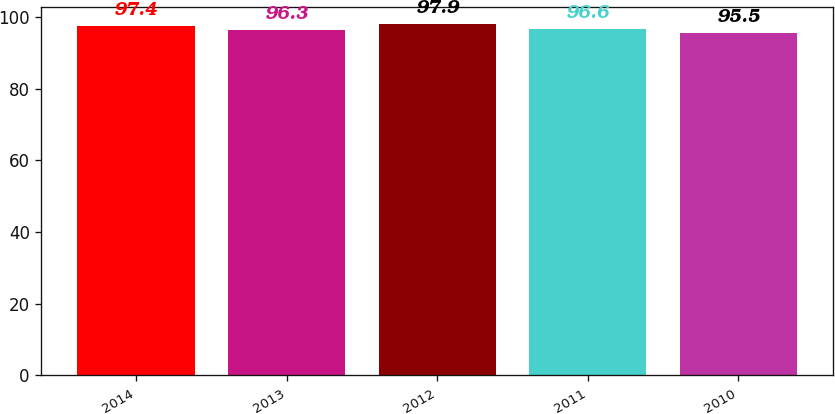Convert chart. <chart><loc_0><loc_0><loc_500><loc_500><bar_chart><fcel>2014<fcel>2013<fcel>2012<fcel>2011<fcel>2010<nl><fcel>97.4<fcel>96.3<fcel>97.9<fcel>96.6<fcel>95.5<nl></chart> 